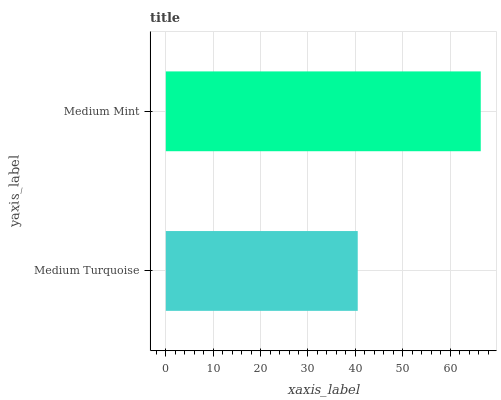Is Medium Turquoise the minimum?
Answer yes or no. Yes. Is Medium Mint the maximum?
Answer yes or no. Yes. Is Medium Mint the minimum?
Answer yes or no. No. Is Medium Mint greater than Medium Turquoise?
Answer yes or no. Yes. Is Medium Turquoise less than Medium Mint?
Answer yes or no. Yes. Is Medium Turquoise greater than Medium Mint?
Answer yes or no. No. Is Medium Mint less than Medium Turquoise?
Answer yes or no. No. Is Medium Mint the high median?
Answer yes or no. Yes. Is Medium Turquoise the low median?
Answer yes or no. Yes. Is Medium Turquoise the high median?
Answer yes or no. No. Is Medium Mint the low median?
Answer yes or no. No. 